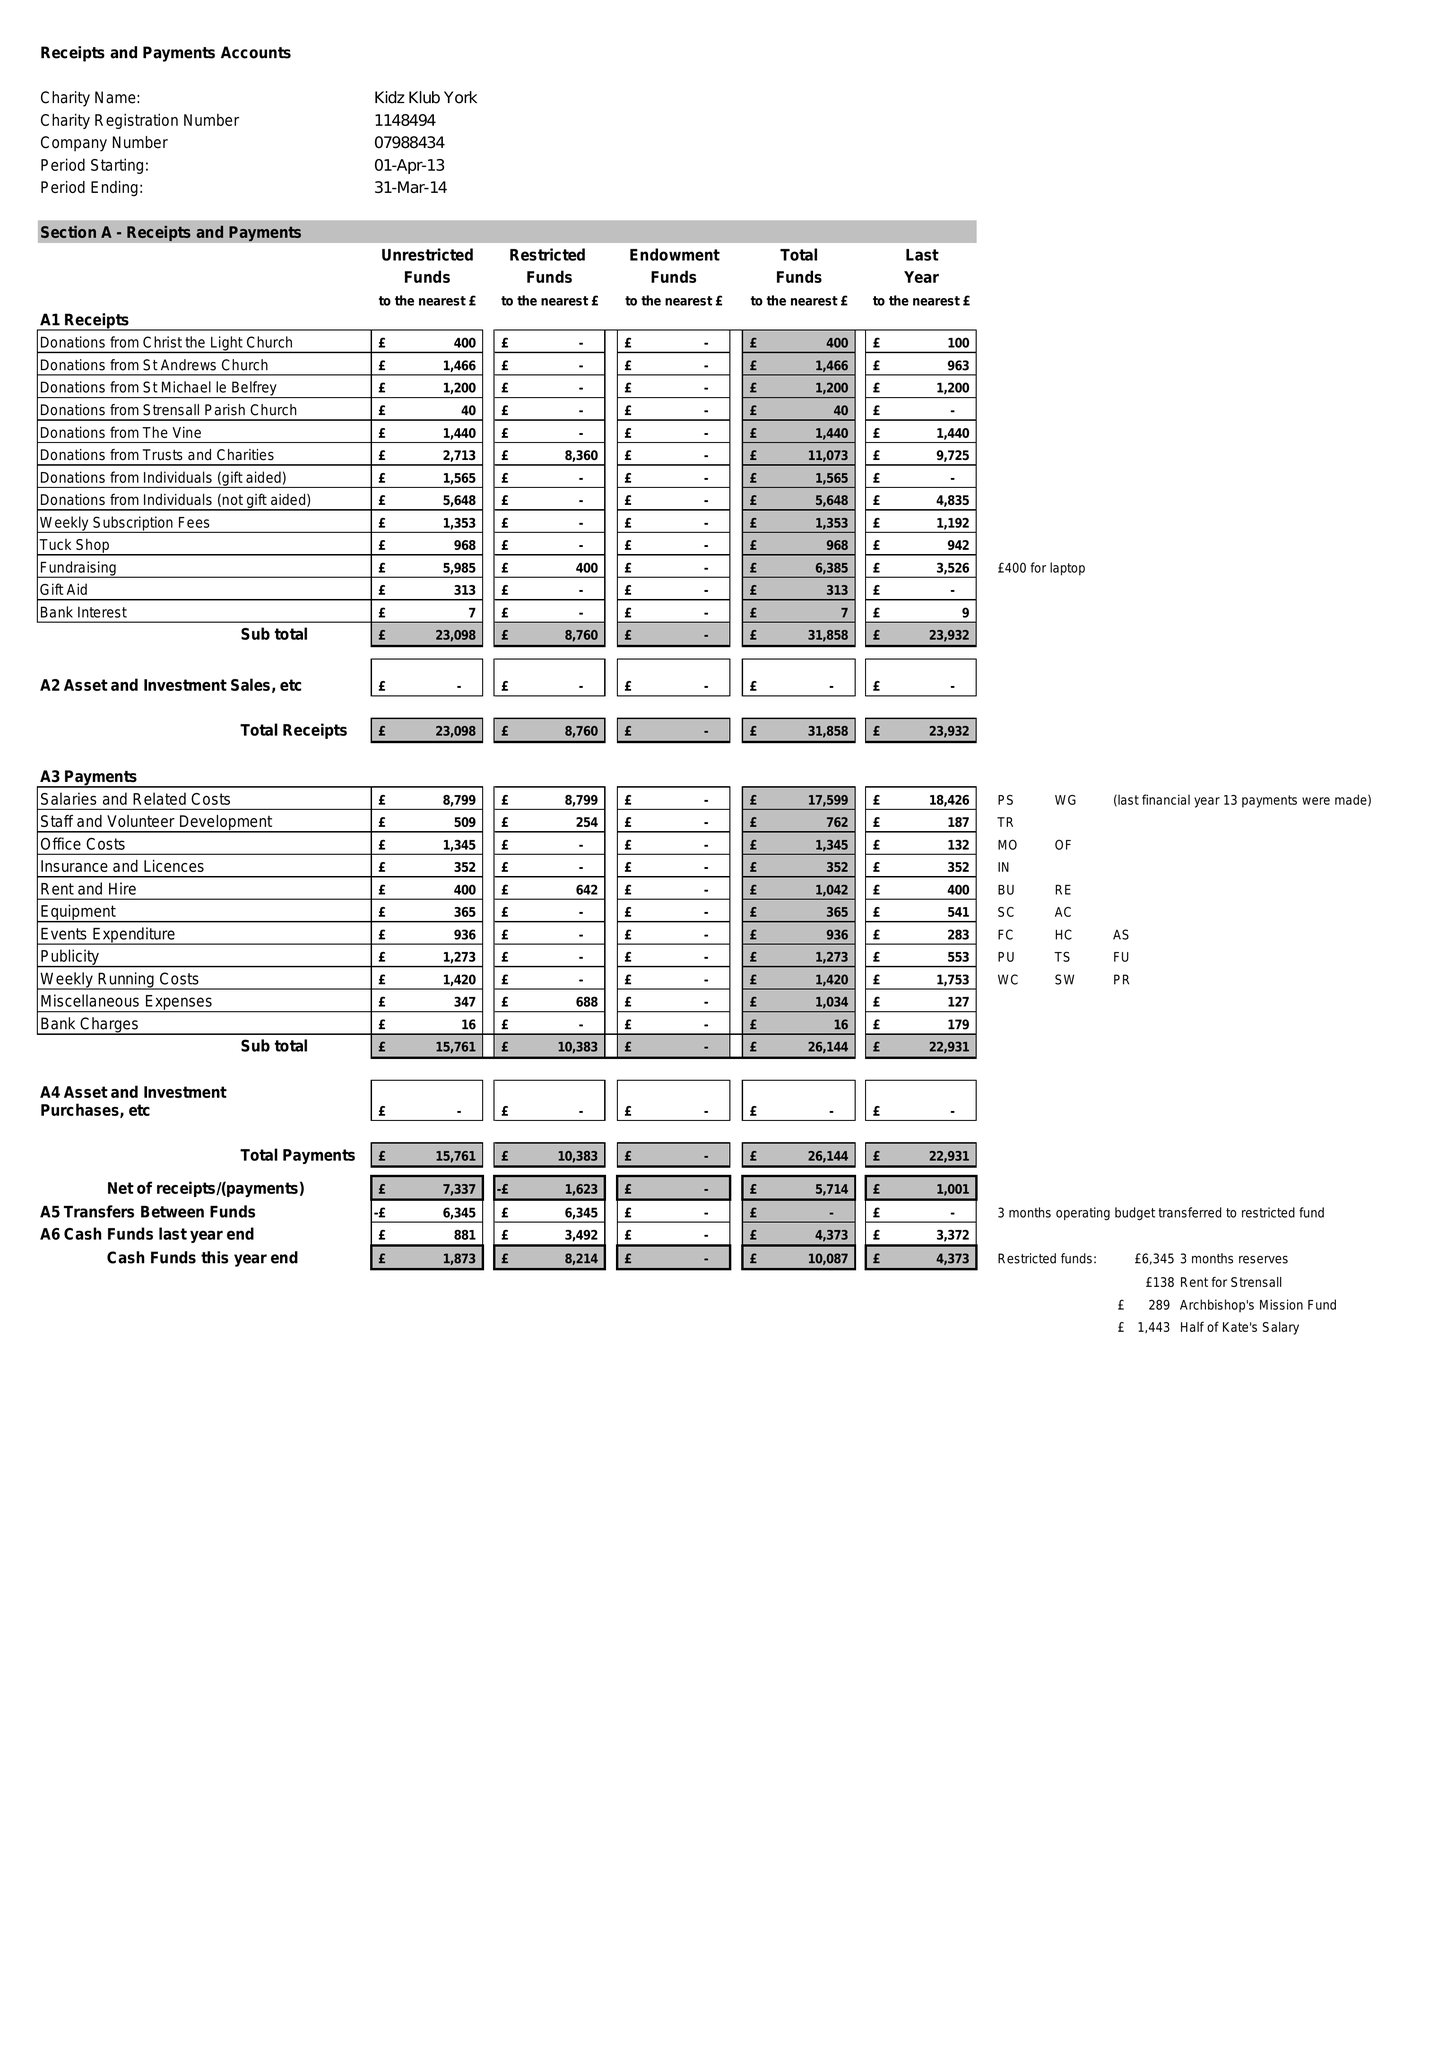What is the value for the charity_name?
Answer the question using a single word or phrase. Kidz Klub York 